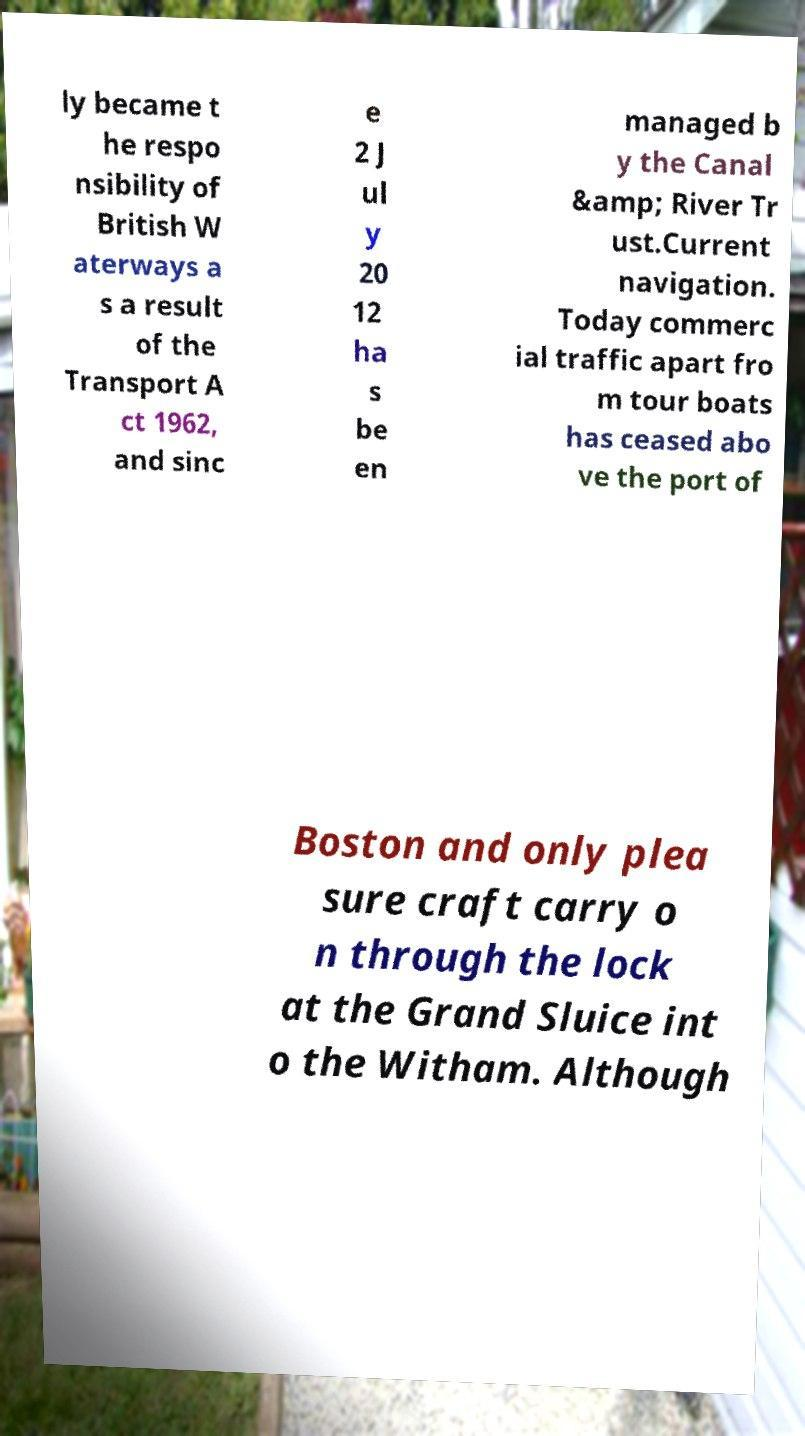I need the written content from this picture converted into text. Can you do that? ly became t he respo nsibility of British W aterways a s a result of the Transport A ct 1962, and sinc e 2 J ul y 20 12 ha s be en managed b y the Canal &amp; River Tr ust.Current navigation. Today commerc ial traffic apart fro m tour boats has ceased abo ve the port of Boston and only plea sure craft carry o n through the lock at the Grand Sluice int o the Witham. Although 